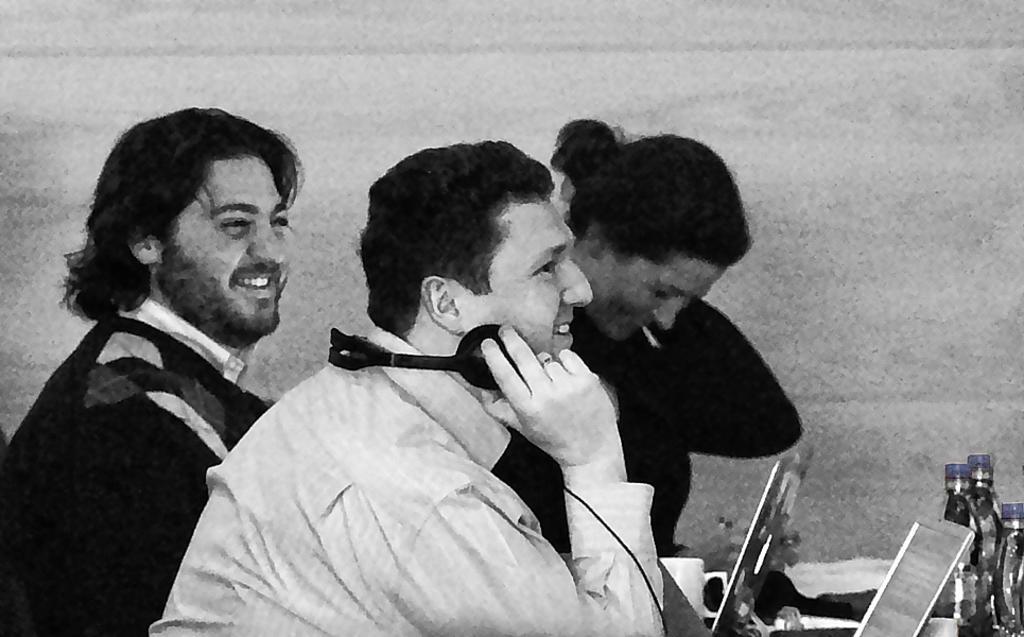Please provide a concise description of this image. In this image I can see few people where I can see smile on their faces. Here I can see laptops and water bottles. 